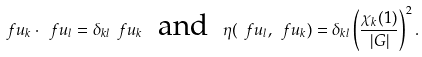Convert formula to latex. <formula><loc_0><loc_0><loc_500><loc_500>\ f u _ { k } \cdot \ f u _ { l } = \delta _ { k l } \ f u _ { k } \ \text { and } \ \eta ( \ f u _ { l } , \ f u _ { k } ) = \delta _ { k l } \left ( \frac { \chi _ { k } ( 1 ) } { | G | } \right ) ^ { 2 } .</formula> 